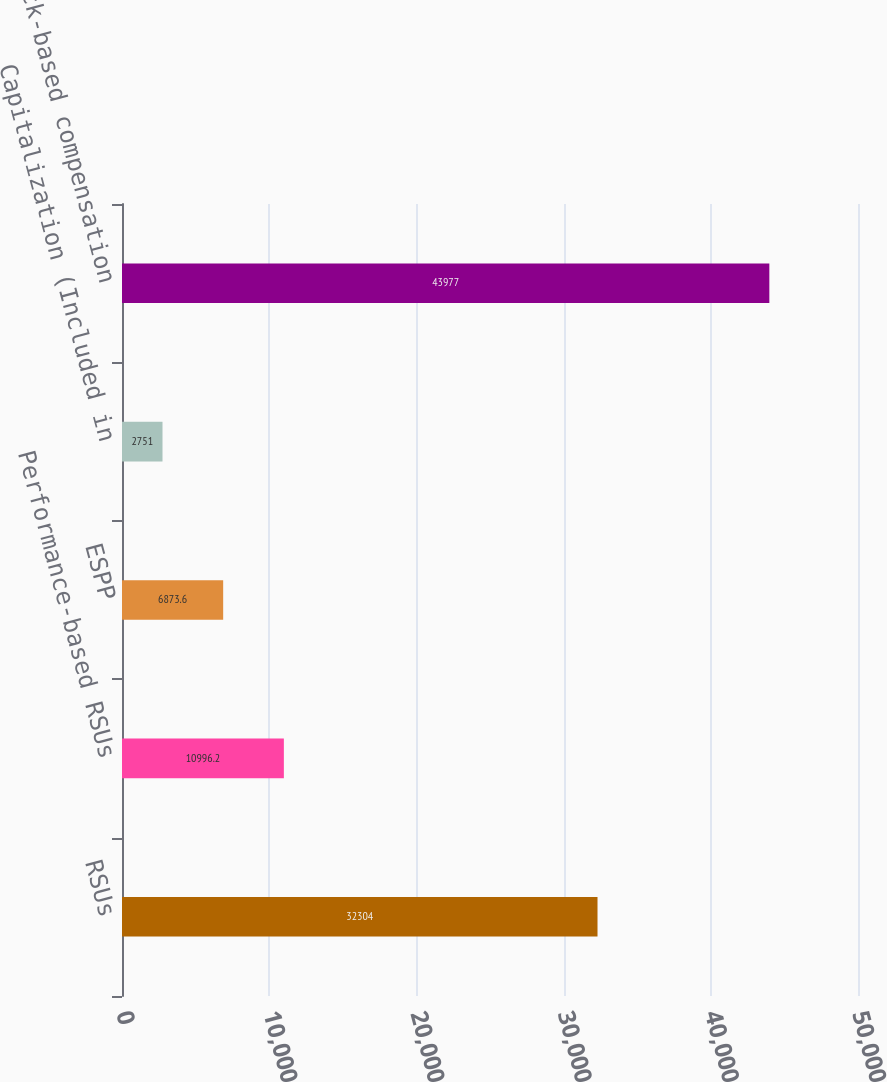Convert chart. <chart><loc_0><loc_0><loc_500><loc_500><bar_chart><fcel>RSUs<fcel>Performance-based RSUs<fcel>ESPP<fcel>Capitalization (Included in<fcel>Total stock-based compensation<nl><fcel>32304<fcel>10996.2<fcel>6873.6<fcel>2751<fcel>43977<nl></chart> 